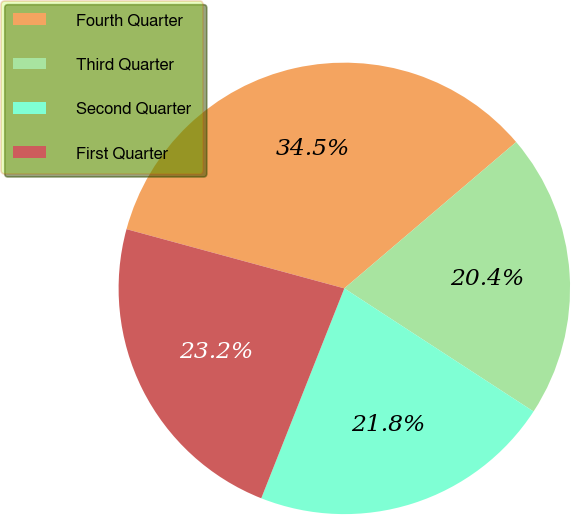Convert chart. <chart><loc_0><loc_0><loc_500><loc_500><pie_chart><fcel>Fourth Quarter<fcel>Third Quarter<fcel>Second Quarter<fcel>First Quarter<nl><fcel>34.55%<fcel>20.41%<fcel>21.82%<fcel>23.23%<nl></chart> 